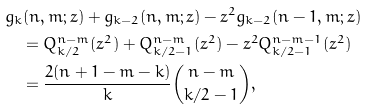<formula> <loc_0><loc_0><loc_500><loc_500>& g _ { k } ( n , m ; z ) + g _ { k - 2 } ( n , m ; z ) - z ^ { 2 } g _ { k - 2 } ( n - 1 , m ; z ) \\ & \quad = Q ^ { n - m } _ { k / 2 } ( z ^ { 2 } ) + Q ^ { n - m } _ { k / 2 - 1 } ( z ^ { 2 } ) - z ^ { 2 } Q ^ { n - m - 1 } _ { k / 2 - 1 } ( z ^ { 2 } ) \\ & \quad = \frac { 2 ( n + 1 - m - k ) } { k } \binom { n - m } { k / 2 - 1 } ,</formula> 